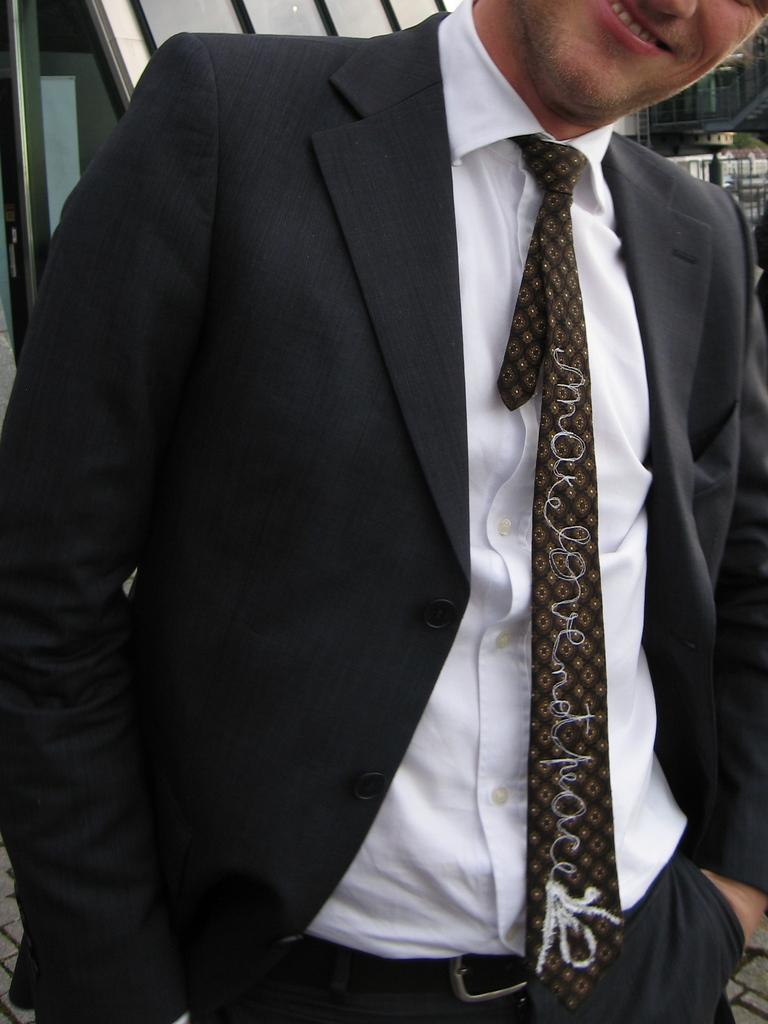Who or what is the main subject in the image? There is a person in the image. What is the person wearing? The person is wearing a black and white dress and a tie. Can you describe the background of the image? There are objects visible in the background of the image. What type of cloth is hanging from the branch in the cellar in the image? There is no branch, cloth, or cellar present in the image. 